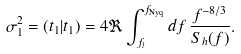Convert formula to latex. <formula><loc_0><loc_0><loc_500><loc_500>\sigma ^ { 2 } _ { 1 } = ( t _ { 1 } | t _ { 1 } ) = 4 \Re \int _ { f _ { l } } ^ { f _ { \text {Nyq} } } d f \, \frac { f ^ { - 8 / 3 } } { S _ { h } ( f ) } .</formula> 